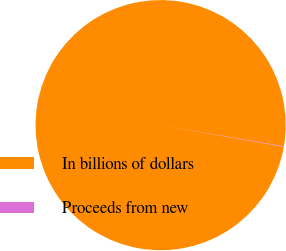Convert chart. <chart><loc_0><loc_0><loc_500><loc_500><pie_chart><fcel>In billions of dollars<fcel>Proceeds from new<nl><fcel>99.94%<fcel>0.06%<nl></chart> 